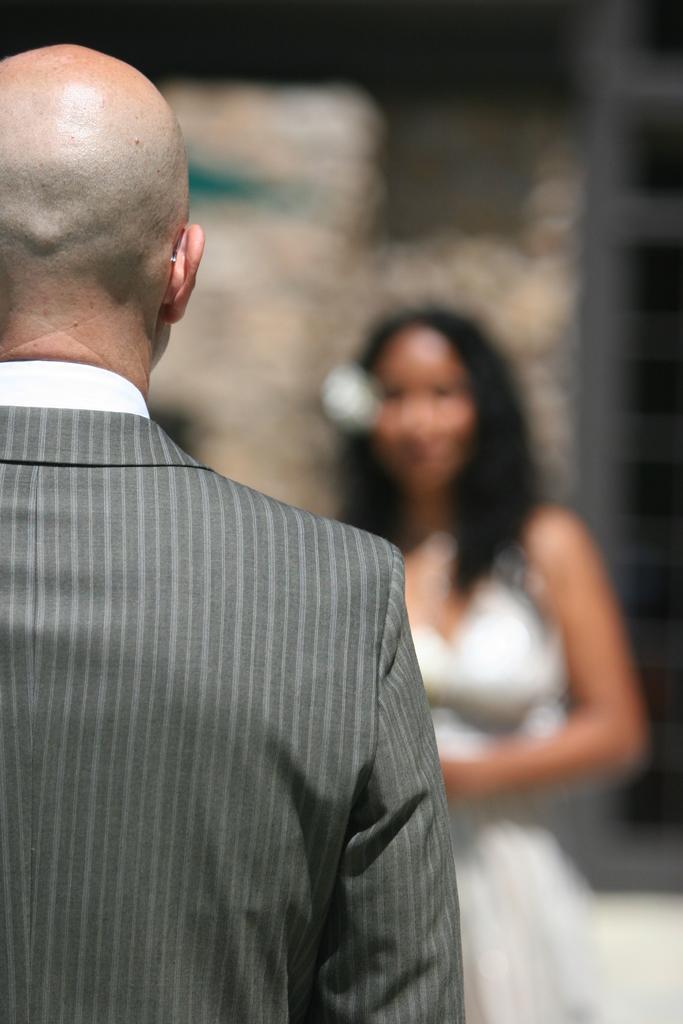Please provide a concise description of this image. On the left we can see a person wearing a grey suit. The background is blurred. In the background we can see a person. 